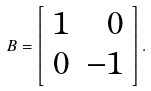<formula> <loc_0><loc_0><loc_500><loc_500>B = \left [ \begin{array} { r r } 1 & 0 \\ 0 & - 1 \\ \end{array} \right ] .</formula> 